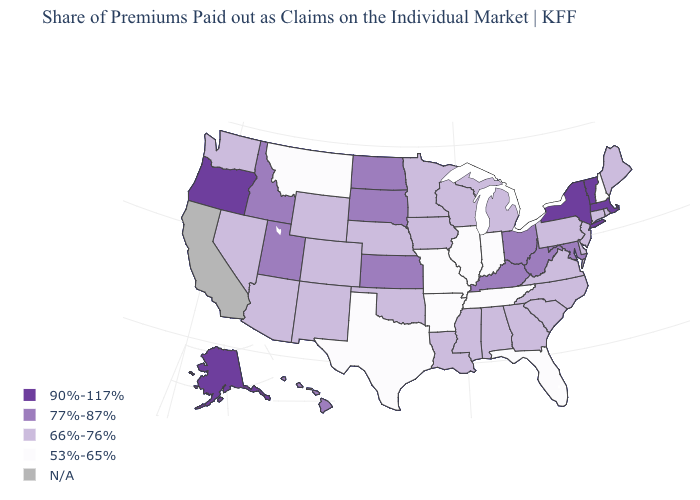What is the value of Delaware?
Answer briefly. 66%-76%. Name the states that have a value in the range 77%-87%?
Short answer required. Hawaii, Idaho, Kansas, Kentucky, Maryland, North Dakota, Ohio, South Dakota, Utah, West Virginia. Which states have the highest value in the USA?
Write a very short answer. Alaska, Massachusetts, New York, Oregon, Vermont. What is the value of North Carolina?
Give a very brief answer. 66%-76%. What is the value of Nevada?
Keep it brief. 66%-76%. Name the states that have a value in the range 66%-76%?
Answer briefly. Alabama, Arizona, Colorado, Connecticut, Delaware, Georgia, Iowa, Louisiana, Maine, Michigan, Minnesota, Mississippi, Nebraska, Nevada, New Jersey, New Mexico, North Carolina, Oklahoma, Pennsylvania, Rhode Island, South Carolina, Virginia, Washington, Wisconsin, Wyoming. Which states have the highest value in the USA?
Quick response, please. Alaska, Massachusetts, New York, Oregon, Vermont. Name the states that have a value in the range 66%-76%?
Quick response, please. Alabama, Arizona, Colorado, Connecticut, Delaware, Georgia, Iowa, Louisiana, Maine, Michigan, Minnesota, Mississippi, Nebraska, Nevada, New Jersey, New Mexico, North Carolina, Oklahoma, Pennsylvania, Rhode Island, South Carolina, Virginia, Washington, Wisconsin, Wyoming. What is the value of Idaho?
Quick response, please. 77%-87%. Does the first symbol in the legend represent the smallest category?
Concise answer only. No. How many symbols are there in the legend?
Concise answer only. 5. Name the states that have a value in the range 53%-65%?
Answer briefly. Arkansas, Florida, Illinois, Indiana, Missouri, Montana, New Hampshire, Tennessee, Texas. Which states have the highest value in the USA?
Write a very short answer. Alaska, Massachusetts, New York, Oregon, Vermont. Name the states that have a value in the range 66%-76%?
Concise answer only. Alabama, Arizona, Colorado, Connecticut, Delaware, Georgia, Iowa, Louisiana, Maine, Michigan, Minnesota, Mississippi, Nebraska, Nevada, New Jersey, New Mexico, North Carolina, Oklahoma, Pennsylvania, Rhode Island, South Carolina, Virginia, Washington, Wisconsin, Wyoming. 